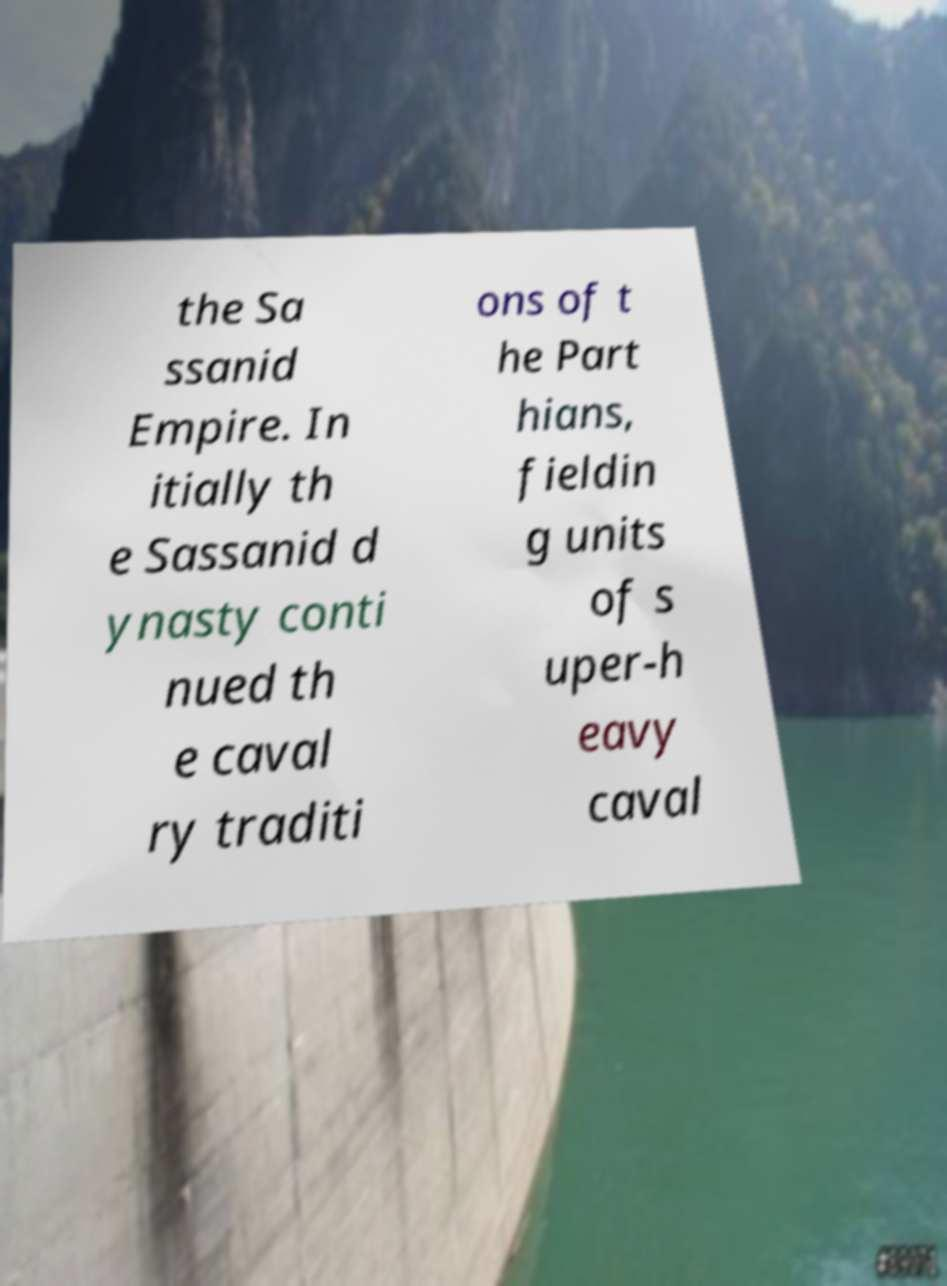Can you accurately transcribe the text from the provided image for me? the Sa ssanid Empire. In itially th e Sassanid d ynasty conti nued th e caval ry traditi ons of t he Part hians, fieldin g units of s uper-h eavy caval 